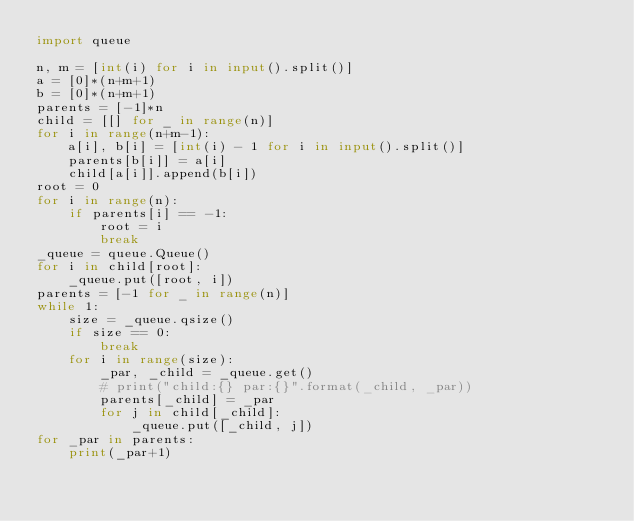Convert code to text. <code><loc_0><loc_0><loc_500><loc_500><_Python_>import queue

n, m = [int(i) for i in input().split()]
a = [0]*(n+m+1)
b = [0]*(n+m+1)
parents = [-1]*n
child = [[] for _ in range(n)]
for i in range(n+m-1):
    a[i], b[i] = [int(i) - 1 for i in input().split()]
    parents[b[i]] = a[i]
    child[a[i]].append(b[i])
root = 0
for i in range(n):
    if parents[i] == -1:
        root = i
        break
_queue = queue.Queue()
for i in child[root]:
    _queue.put([root, i])
parents = [-1 for _ in range(n)]
while 1:
    size = _queue.qsize()
    if size == 0:
        break
    for i in range(size):
        _par, _child = _queue.get()
        # print("child:{} par:{}".format(_child, _par))
        parents[_child] = _par
        for j in child[_child]:
            _queue.put([_child, j])
for _par in parents:
    print(_par+1)
</code> 